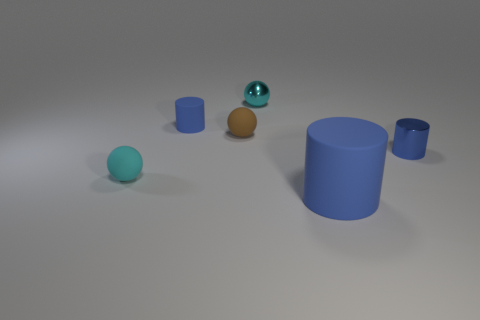Subtract all purple blocks. How many cyan spheres are left? 2 Add 2 small blue matte cylinders. How many objects exist? 8 Subtract all big rubber cylinders. How many cylinders are left? 2 Subtract all tiny cyan objects. Subtract all brown spheres. How many objects are left? 3 Add 4 large rubber things. How many large rubber things are left? 5 Add 6 big blue matte cylinders. How many big blue matte cylinders exist? 7 Subtract 0 gray cylinders. How many objects are left? 6 Subtract all green spheres. Subtract all blue cubes. How many spheres are left? 3 